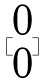<formula> <loc_0><loc_0><loc_500><loc_500>[ \begin{matrix} 0 \\ 0 \end{matrix} ]</formula> 